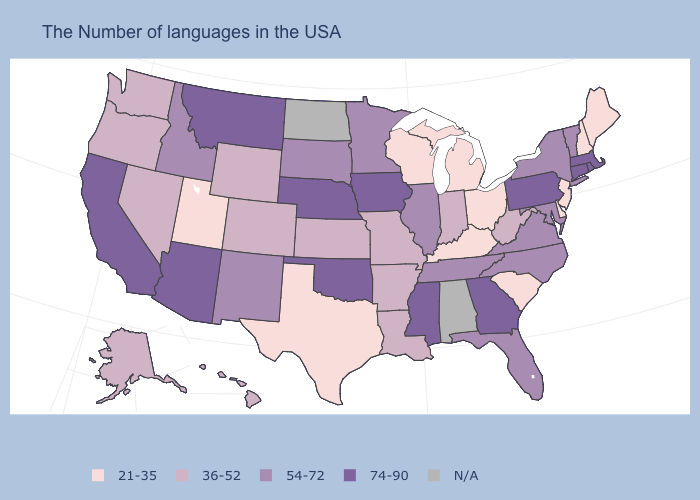Among the states that border West Virginia , which have the lowest value?
Concise answer only. Ohio, Kentucky. Which states have the highest value in the USA?
Be succinct. Massachusetts, Rhode Island, Connecticut, Pennsylvania, Georgia, Mississippi, Iowa, Nebraska, Oklahoma, Montana, Arizona, California. Does the first symbol in the legend represent the smallest category?
Write a very short answer. Yes. Among the states that border New Mexico , does Oklahoma have the lowest value?
Give a very brief answer. No. Name the states that have a value in the range 21-35?
Give a very brief answer. Maine, New Hampshire, New Jersey, Delaware, South Carolina, Ohio, Michigan, Kentucky, Wisconsin, Texas, Utah. Name the states that have a value in the range 74-90?
Quick response, please. Massachusetts, Rhode Island, Connecticut, Pennsylvania, Georgia, Mississippi, Iowa, Nebraska, Oklahoma, Montana, Arizona, California. What is the value of Nebraska?
Be succinct. 74-90. What is the lowest value in the USA?
Concise answer only. 21-35. What is the value of Wyoming?
Keep it brief. 36-52. Among the states that border Montana , does South Dakota have the lowest value?
Answer briefly. No. What is the value of Wisconsin?
Answer briefly. 21-35. What is the value of Utah?
Write a very short answer. 21-35. What is the lowest value in the South?
Write a very short answer. 21-35. Name the states that have a value in the range 21-35?
Be succinct. Maine, New Hampshire, New Jersey, Delaware, South Carolina, Ohio, Michigan, Kentucky, Wisconsin, Texas, Utah. Name the states that have a value in the range N/A?
Short answer required. Alabama, North Dakota. 